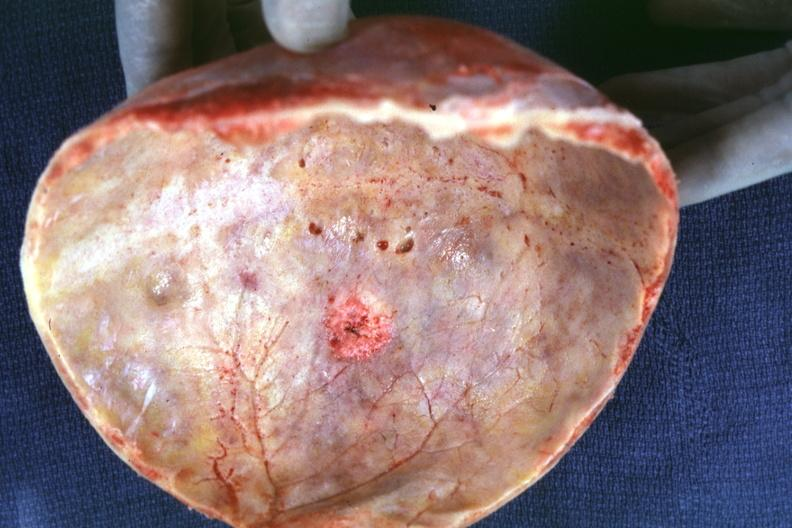what does this image show?
Answer the question using a single word or phrase. Skull cap with obvious metastatic lesion seen on inner table prostate primary 